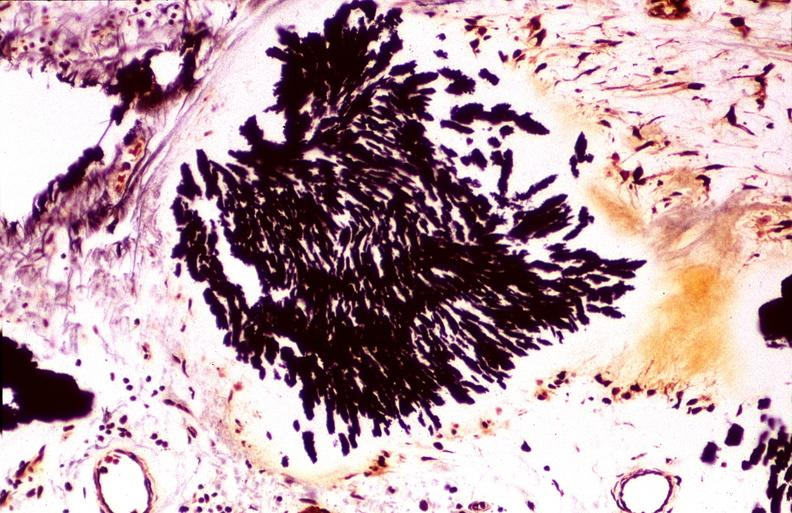what is present?
Answer the question using a single word or phrase. Joints 